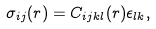Convert formula to latex. <formula><loc_0><loc_0><loc_500><loc_500>\sigma _ { i j } ( r ) = C _ { i j k l } ( r ) \epsilon _ { l k } ,</formula> 